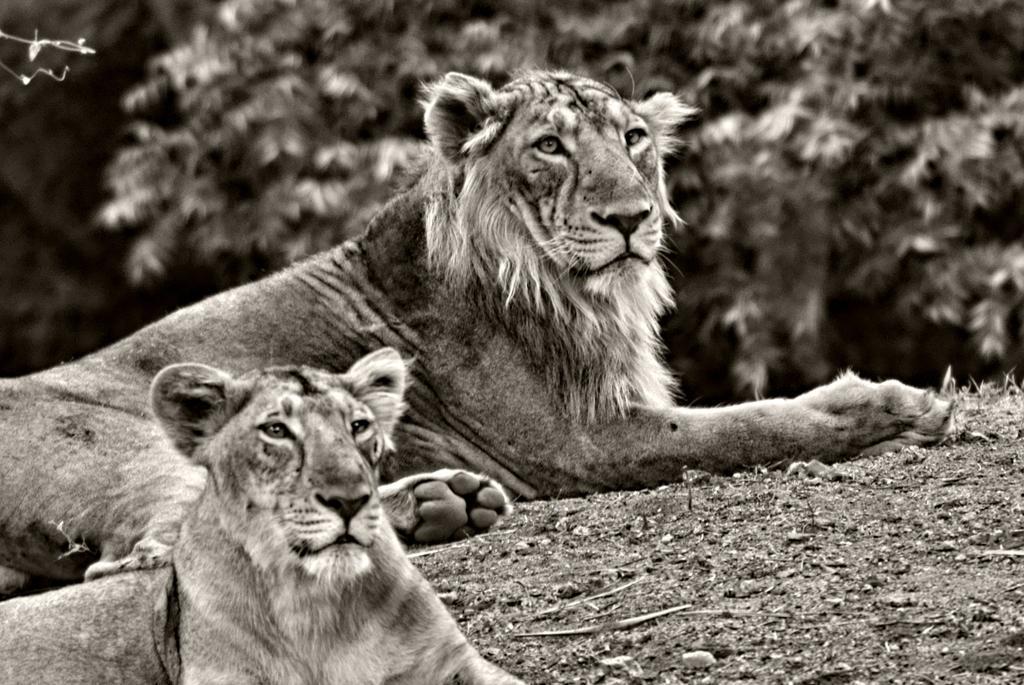Could you give a brief overview of what you see in this image? In this image there are two lions on surface of the ground. At the back side there are trees. 